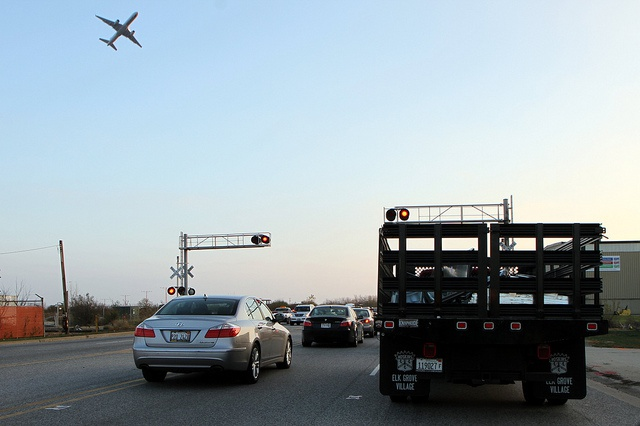Describe the objects in this image and their specific colors. I can see truck in lightblue, black, ivory, gray, and darkgray tones, car in lightblue, black, and gray tones, car in lightblue, black, purple, and maroon tones, airplane in lightblue, gray, black, and darkblue tones, and car in lightblue, black, gray, ivory, and darkgray tones in this image. 